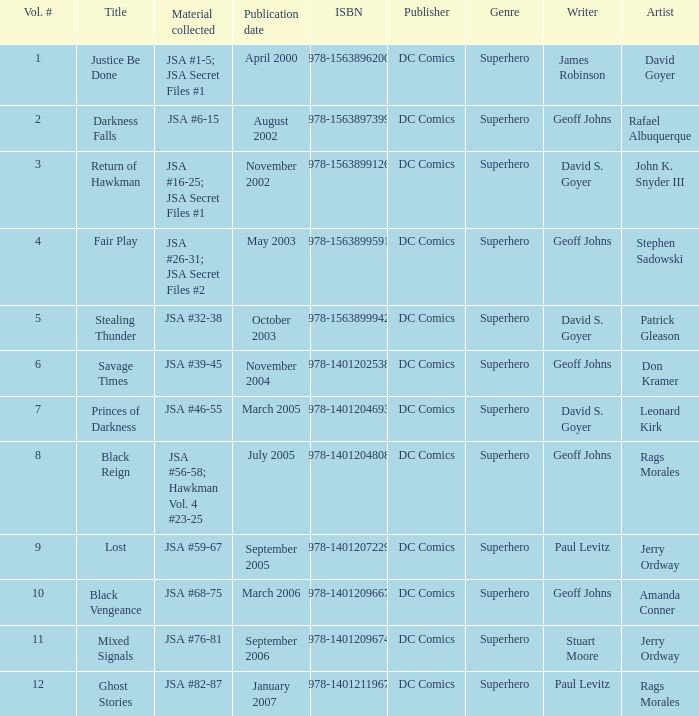How many Volume Numbers have the title of Darkness Falls? 2.0. 